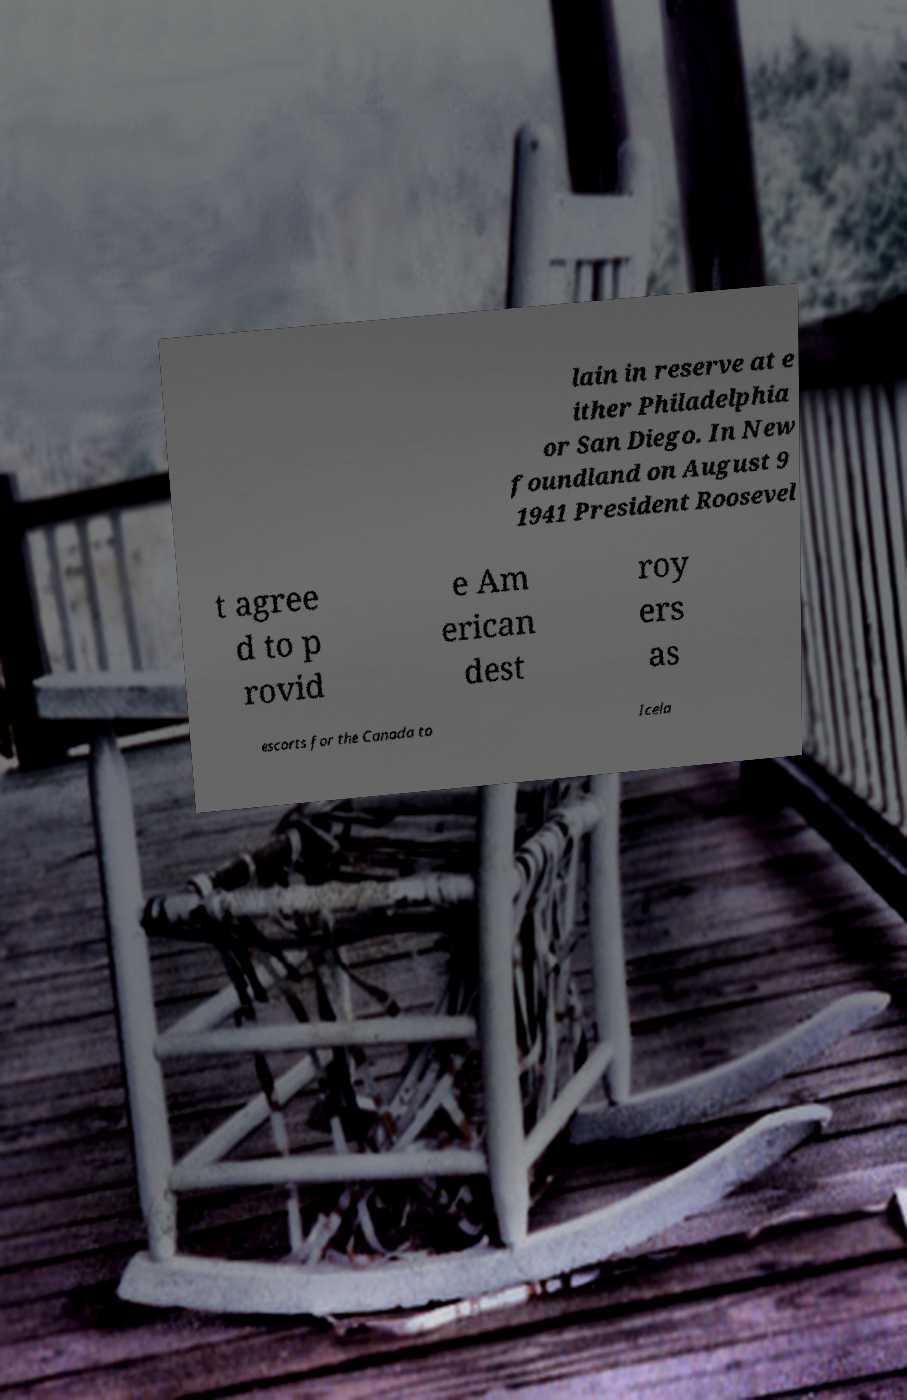Can you read and provide the text displayed in the image?This photo seems to have some interesting text. Can you extract and type it out for me? lain in reserve at e ither Philadelphia or San Diego. In New foundland on August 9 1941 President Roosevel t agree d to p rovid e Am erican dest roy ers as escorts for the Canada to Icela 